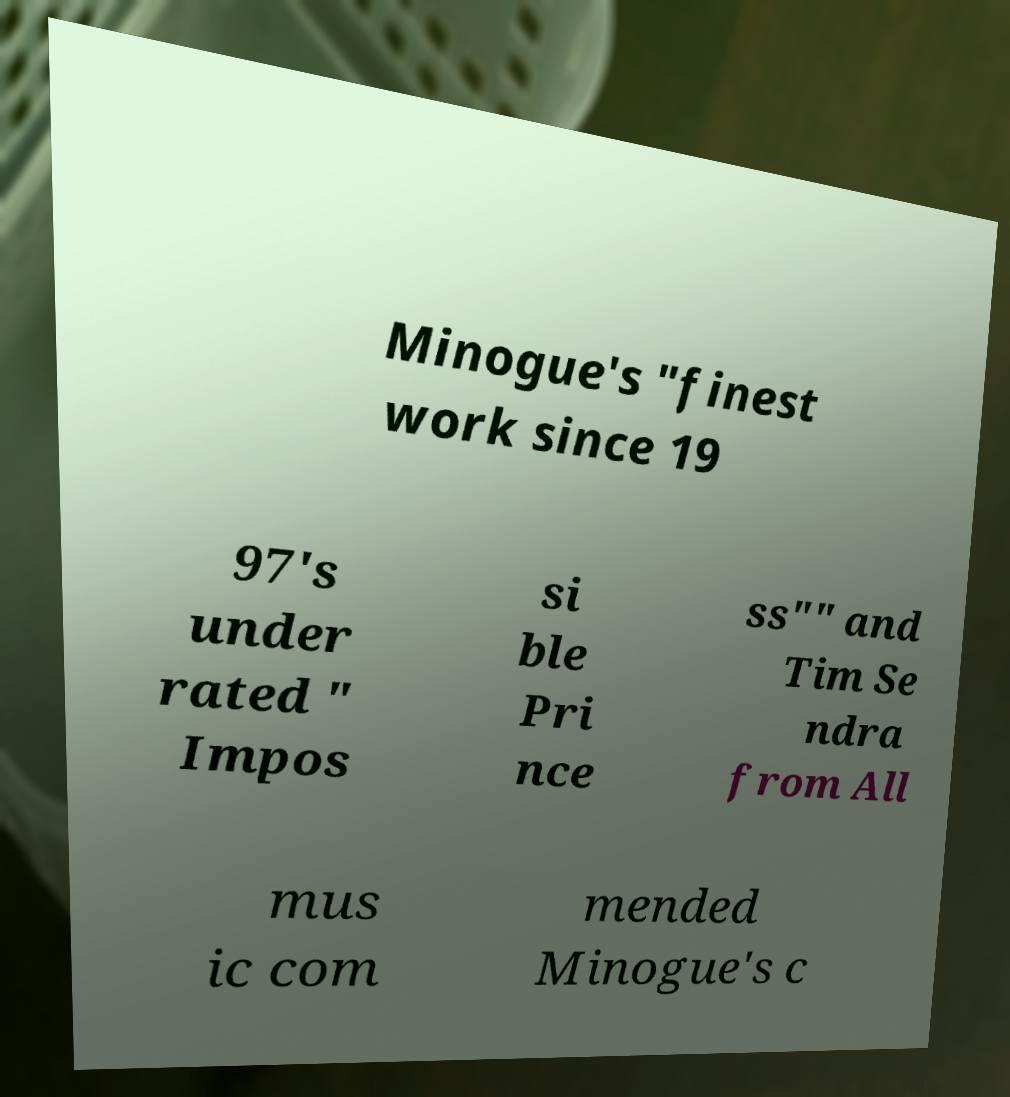Could you extract and type out the text from this image? Minogue's "finest work since 19 97's under rated " Impos si ble Pri nce ss"" and Tim Se ndra from All mus ic com mended Minogue's c 